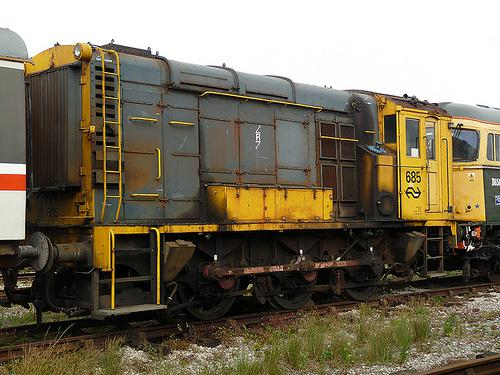Question: what color are the wheels?
Choices:
A. Grey.
B. Brown.
C. Silver.
D. Black.
Answer with the letter. Answer: D Question: where are the railroad tracks?
Choices:
A. On the road.
B. By the car.
C. Under train.
D. In the yard.
Answer with the letter. Answer: C Question: what form of transportation is this?
Choices:
A. Car.
B. Bus.
C. Airplane.
D. Train.
Answer with the letter. Answer: D Question: how many trains are in this picture?
Choices:
A. 1.
B. 2.
C. 4.
D. 6.
Answer with the letter. Answer: A Question: what color is the door?
Choices:
A. Red.
B. Brown.
C. Yellow.
D. Black.
Answer with the letter. Answer: C 